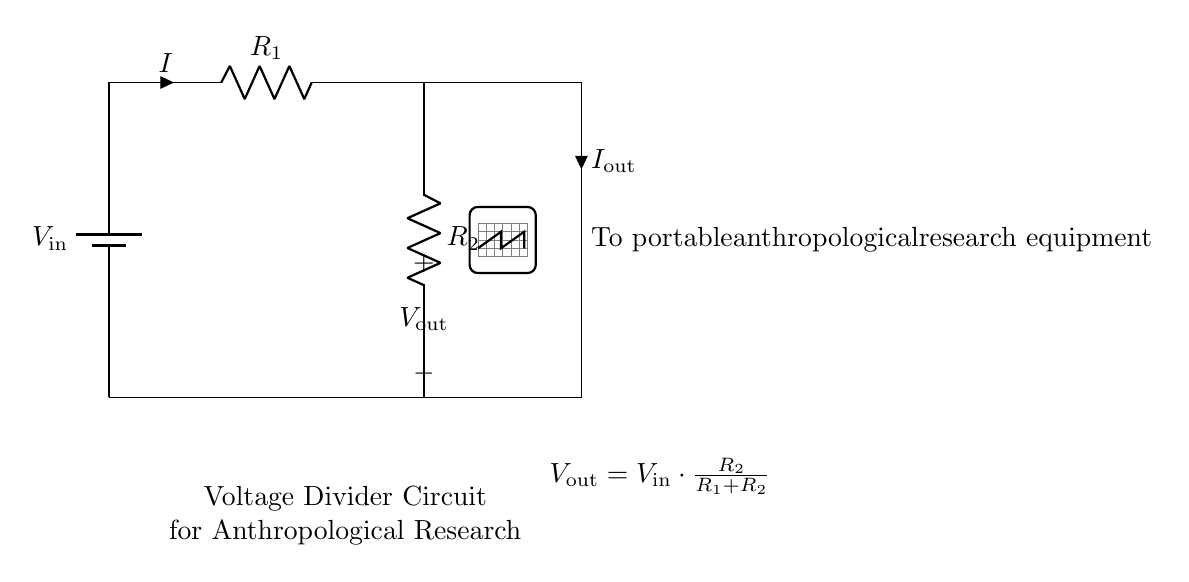What is the input voltage in this circuit? The input voltage is labeled as V_in in the circuit diagram and represents the voltage supplied by the battery.
Answer: V_in What are the values of the resistors in the circuit? The resistors are labeled as R_1 and R_2 in the circuit diagram, but their specific values are not indicated here.
Answer: R_1 and R_2 What is the output voltage formula in the circuit? The formula for the output voltage is provided in the circuit diagram as V_out = V_in * (R_2 / (R_1 + R_2)). This shows how the output voltage is calculated based on the resistor values and the input voltage.
Answer: V_out = V_in * (R_2 / (R_1 + R_2)) How does the output voltage depend on the resistors? The output voltage is directly dependent on the ratio of the resistors, with R_2 in the numerator and the sum of R_1 and R_2 in the denominator of the formula provided. This indicates that changing the resistors' values alters the output voltage.
Answer: It depends on R_1 and R_2 Which component delivers current to the research equipment? The current flows from the output of the voltage divider circuit to the portable anthropological research equipment, where it is indicated in the diagram that it is labeled as I_out.
Answer: I_out Why is a voltage divider used in this circuit? A voltage divider is used to reduce the input voltage to a suitable level for the portable research equipment to operate. This is crucial for ensuring that the equipment functions correctly without being damaged by excess voltage.
Answer: To reduce voltage for the equipment 